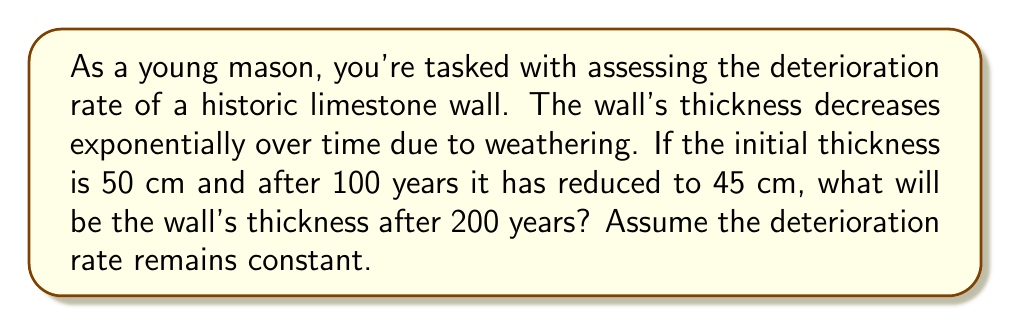Provide a solution to this math problem. Let's approach this step-by-step using exponential decay:

1) The general formula for exponential decay is:
   $$A(t) = A_0 e^{-kt}$$
   where $A(t)$ is the amount at time $t$, $A_0$ is the initial amount, $k$ is the decay constant, and $t$ is time.

2) We know:
   $A_0 = 50$ cm (initial thickness)
   $A(100) = 45$ cm (thickness after 100 years)
   
3) Let's find $k$ using the given information:
   $$45 = 50e^{-k(100)}$$

4) Dividing both sides by 50:
   $$0.9 = e^{-100k}$$

5) Taking natural log of both sides:
   $$\ln(0.9) = -100k$$

6) Solving for $k$:
   $$k = -\frac{\ln(0.9)}{100} \approx 0.001054$$

7) Now we can use this $k$ to find the thickness after 200 years:
   $$A(200) = 50e^{-0.001054(200)}$$

8) Calculating this:
   $$A(200) \approx 40.5$$

Therefore, after 200 years, the wall's thickness will be approximately 40.5 cm.
Answer: 40.5 cm 